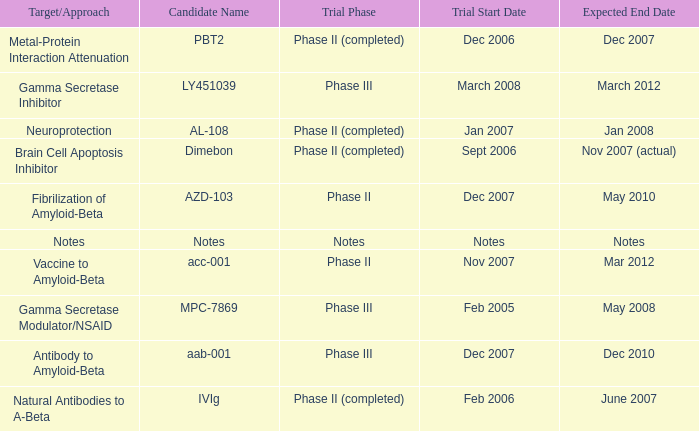What is Expected End Date, when Target/Approach is Notes? Notes. 